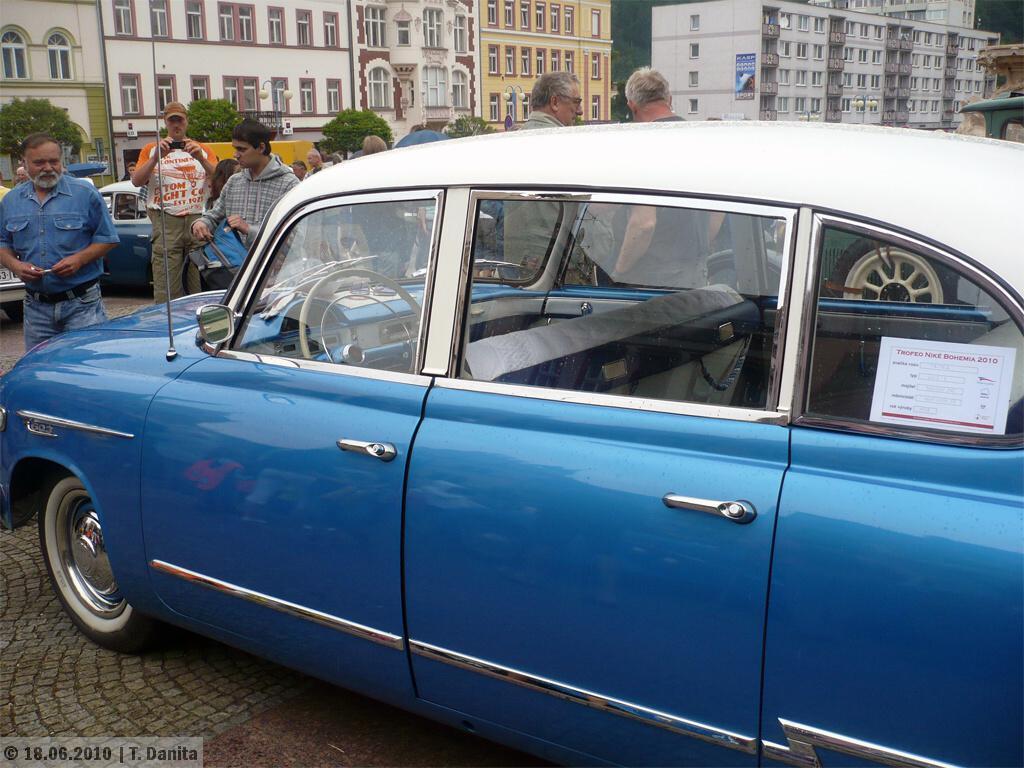In one or two sentences, can you explain what this image depicts? There is a blue color car in the middle of this image. There are some persons standing and some trees are present in the background. There are some buildings in the background. There are some other cars on the left side of this image. 